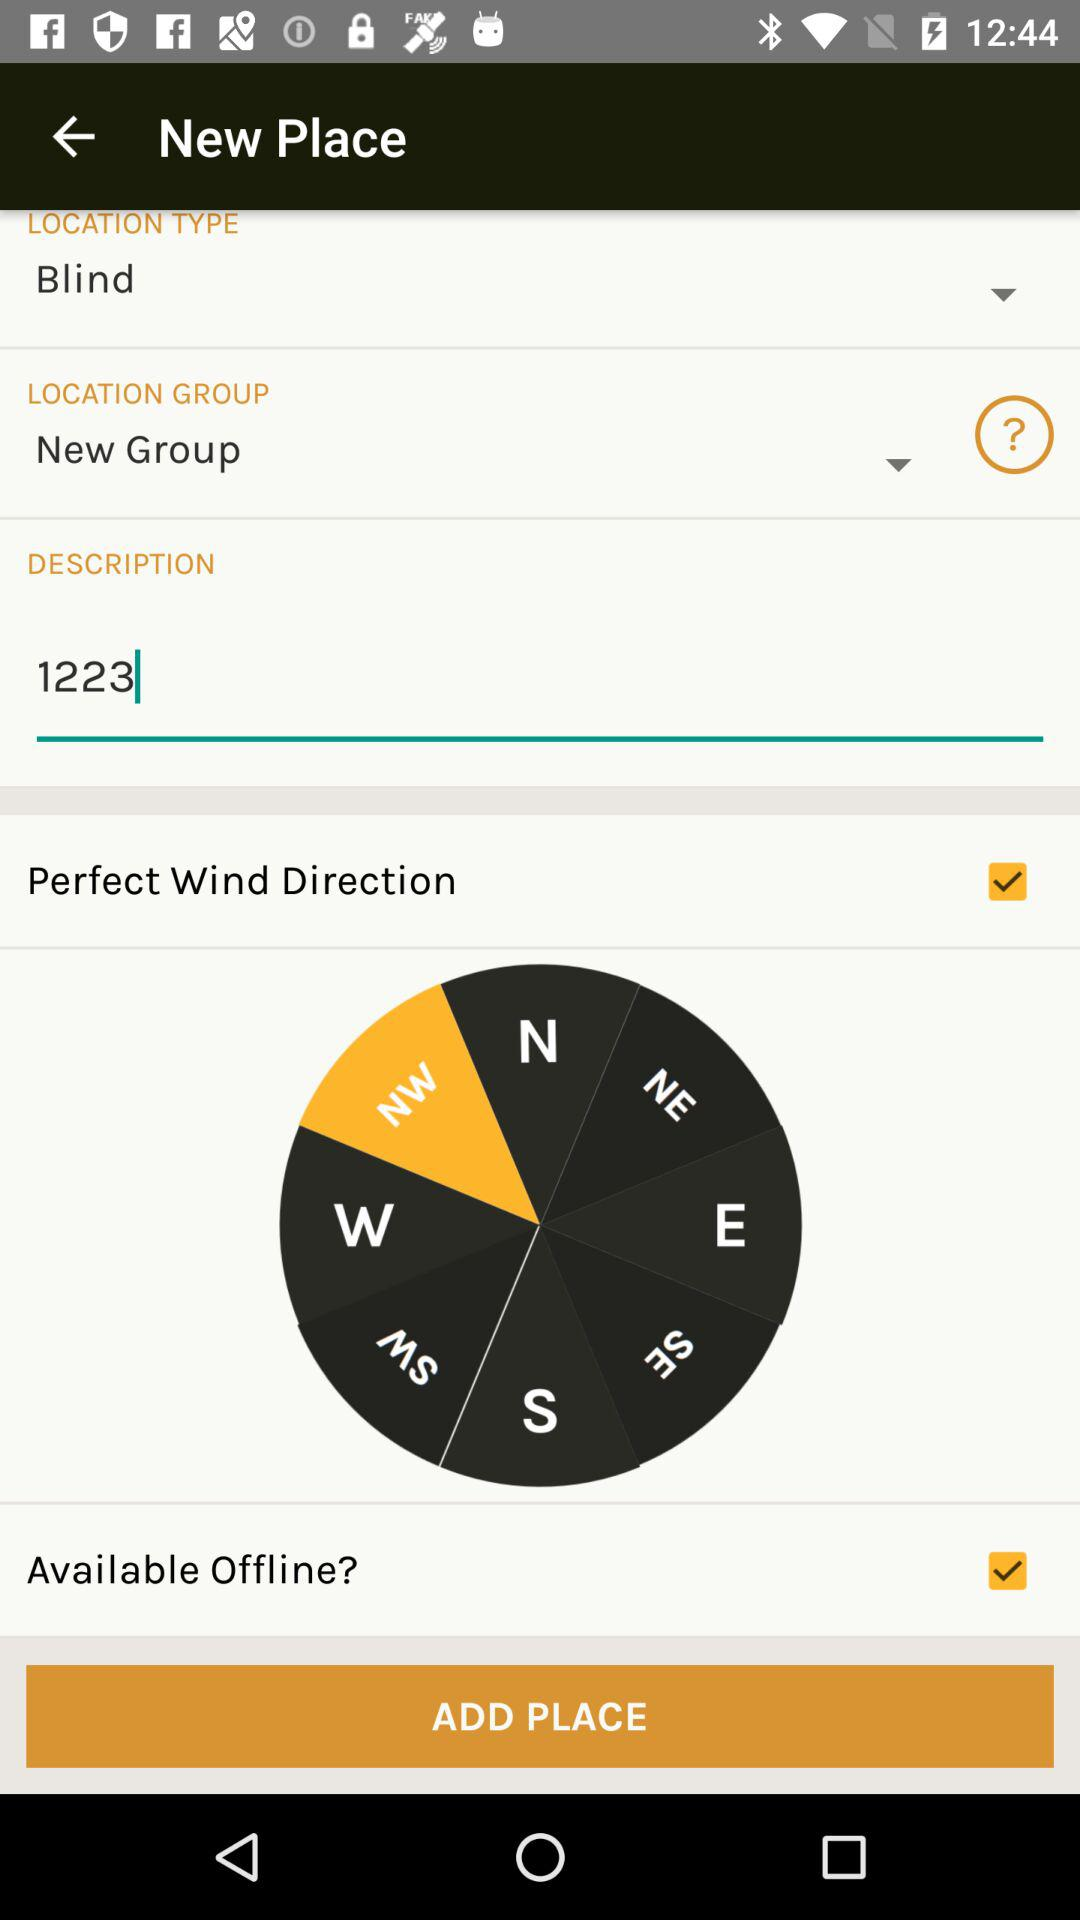What is the status of the "Available Offline" setting? The status of the "Available Offline" setting is "on". 